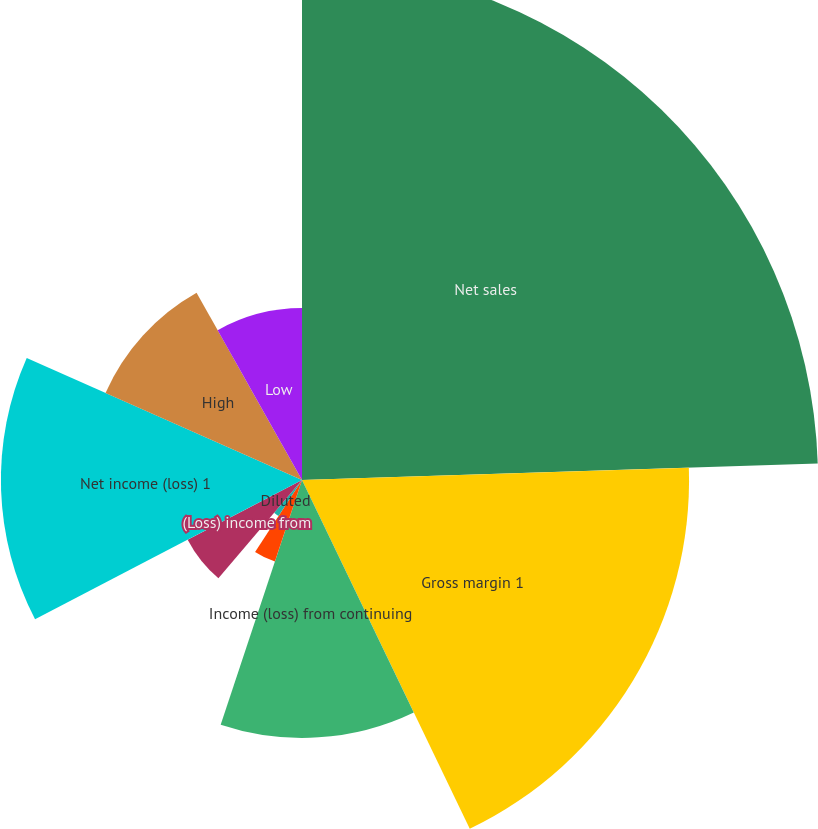Convert chart to OTSL. <chart><loc_0><loc_0><loc_500><loc_500><pie_chart><fcel>Net sales<fcel>Gross margin 1<fcel>Income (loss) from continuing<fcel>Basic<fcel>Diluted<fcel>(Loss) income from<fcel>Net income (loss) 1<fcel>Cash dividends declared per<fcel>High<fcel>Low<nl><fcel>24.49%<fcel>18.37%<fcel>12.24%<fcel>4.08%<fcel>2.04%<fcel>6.12%<fcel>14.29%<fcel>0.0%<fcel>10.2%<fcel>8.16%<nl></chart> 